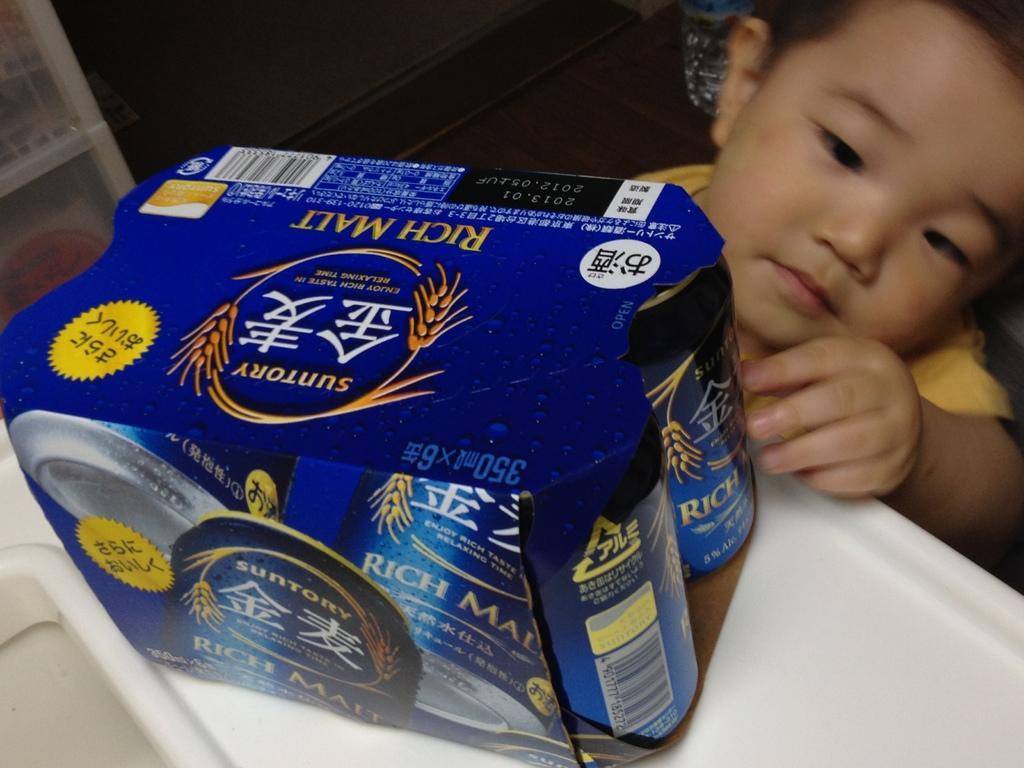Can you describe this image briefly? As we can see in the image there is a boy wearing yellow color shirt and there is table. On table there is box. 